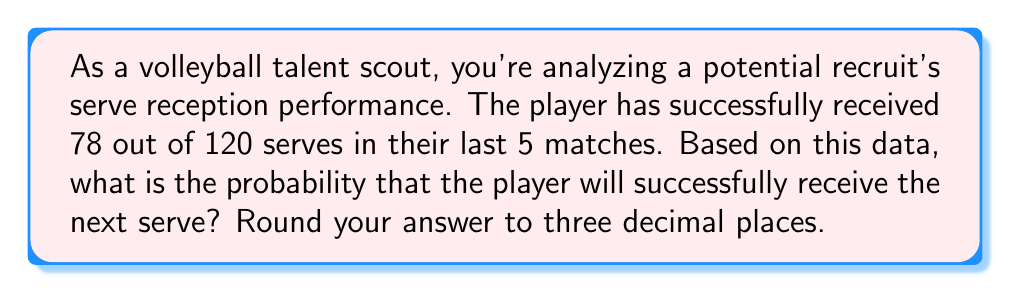What is the answer to this math problem? To solve this problem, we need to use the concept of empirical probability. Empirical probability is based on observed data and is calculated by dividing the number of favorable outcomes by the total number of trials.

Let's define our variables:
$s$ = number of successful receptions
$t$ = total number of serve reception attempts

From the given data:
$s = 78$
$t = 120$

The empirical probability formula is:

$$ P(\text{success}) = \frac{\text{number of favorable outcomes}}{\text{total number of trials}} = \frac{s}{t} $$

Substituting our values:

$$ P(\text{successful reception}) = \frac{78}{120} $$

To calculate this:

$$ \frac{78}{120} = 0.65 $$

Rounding to three decimal places:

$$ 0.65 = 0.650 $$

Therefore, based on the player's past performance, the probability of successfully receiving the next serve is 0.650 or 65.0%.
Answer: 0.650 